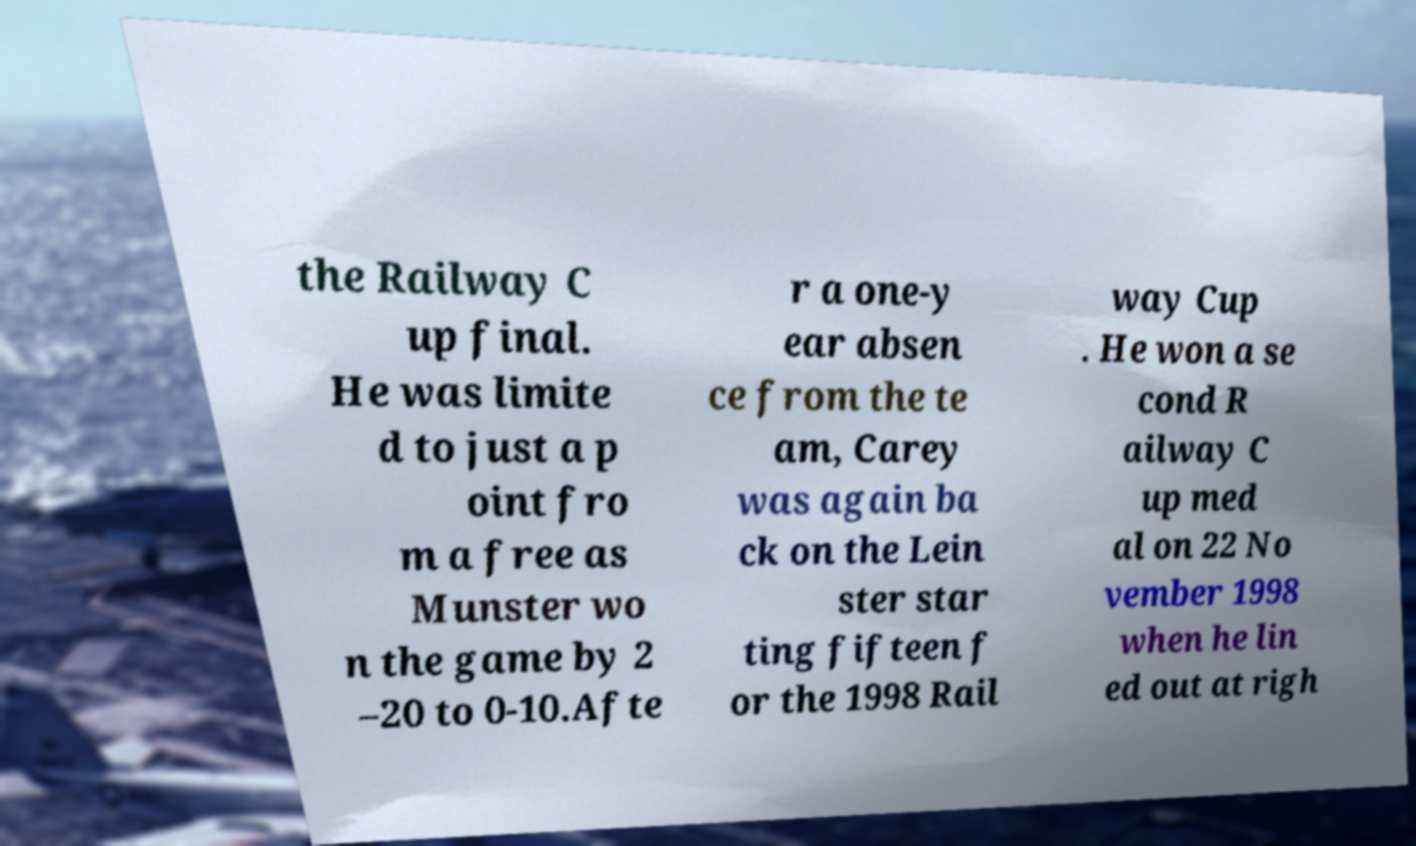For documentation purposes, I need the text within this image transcribed. Could you provide that? the Railway C up final. He was limite d to just a p oint fro m a free as Munster wo n the game by 2 –20 to 0-10.Afte r a one-y ear absen ce from the te am, Carey was again ba ck on the Lein ster star ting fifteen f or the 1998 Rail way Cup . He won a se cond R ailway C up med al on 22 No vember 1998 when he lin ed out at righ 